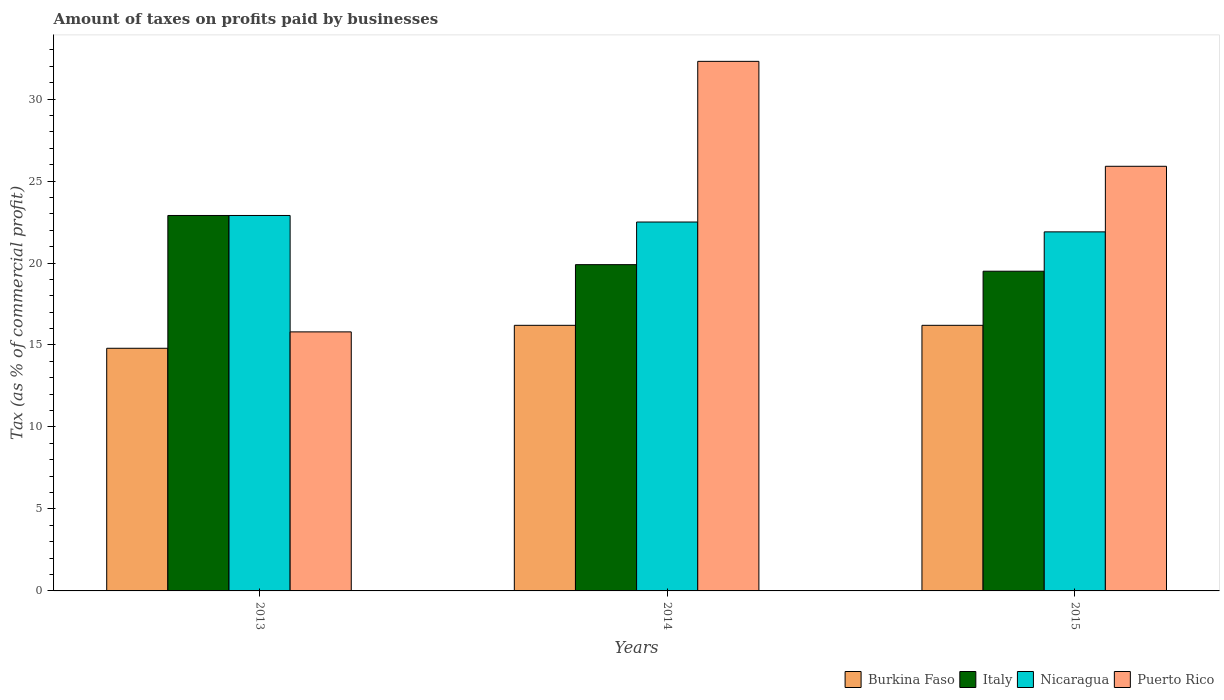How many groups of bars are there?
Offer a very short reply. 3. Are the number of bars per tick equal to the number of legend labels?
Provide a short and direct response. Yes. Are the number of bars on each tick of the X-axis equal?
Ensure brevity in your answer.  Yes. How many bars are there on the 1st tick from the right?
Provide a succinct answer. 4. What is the label of the 1st group of bars from the left?
Offer a very short reply. 2013. What is the percentage of taxes paid by businesses in Italy in 2015?
Your response must be concise. 19.5. Across all years, what is the maximum percentage of taxes paid by businesses in Italy?
Offer a very short reply. 22.9. In which year was the percentage of taxes paid by businesses in Italy maximum?
Provide a succinct answer. 2013. In which year was the percentage of taxes paid by businesses in Nicaragua minimum?
Your response must be concise. 2015. What is the difference between the percentage of taxes paid by businesses in Nicaragua in 2013 and that in 2014?
Ensure brevity in your answer.  0.4. What is the difference between the percentage of taxes paid by businesses in Nicaragua in 2015 and the percentage of taxes paid by businesses in Puerto Rico in 2013?
Provide a succinct answer. 6.1. What is the average percentage of taxes paid by businesses in Nicaragua per year?
Offer a very short reply. 22.43. In the year 2015, what is the difference between the percentage of taxes paid by businesses in Italy and percentage of taxes paid by businesses in Burkina Faso?
Your response must be concise. 3.3. What is the ratio of the percentage of taxes paid by businesses in Burkina Faso in 2013 to that in 2014?
Keep it short and to the point. 0.91. What is the difference between the highest and the second highest percentage of taxes paid by businesses in Puerto Rico?
Provide a succinct answer. 6.4. What is the difference between the highest and the lowest percentage of taxes paid by businesses in Italy?
Your response must be concise. 3.4. Is the sum of the percentage of taxes paid by businesses in Burkina Faso in 2013 and 2014 greater than the maximum percentage of taxes paid by businesses in Puerto Rico across all years?
Your answer should be very brief. No. What does the 4th bar from the left in 2014 represents?
Offer a very short reply. Puerto Rico. How many bars are there?
Offer a very short reply. 12. Are all the bars in the graph horizontal?
Give a very brief answer. No. How many years are there in the graph?
Keep it short and to the point. 3. Does the graph contain grids?
Your answer should be very brief. No. How are the legend labels stacked?
Your answer should be compact. Horizontal. What is the title of the graph?
Give a very brief answer. Amount of taxes on profits paid by businesses. What is the label or title of the Y-axis?
Ensure brevity in your answer.  Tax (as % of commercial profit). What is the Tax (as % of commercial profit) of Italy in 2013?
Your answer should be compact. 22.9. What is the Tax (as % of commercial profit) in Nicaragua in 2013?
Ensure brevity in your answer.  22.9. What is the Tax (as % of commercial profit) of Burkina Faso in 2014?
Your response must be concise. 16.2. What is the Tax (as % of commercial profit) in Italy in 2014?
Provide a short and direct response. 19.9. What is the Tax (as % of commercial profit) of Puerto Rico in 2014?
Provide a short and direct response. 32.3. What is the Tax (as % of commercial profit) in Nicaragua in 2015?
Offer a terse response. 21.9. What is the Tax (as % of commercial profit) of Puerto Rico in 2015?
Provide a short and direct response. 25.9. Across all years, what is the maximum Tax (as % of commercial profit) in Italy?
Make the answer very short. 22.9. Across all years, what is the maximum Tax (as % of commercial profit) of Nicaragua?
Provide a succinct answer. 22.9. Across all years, what is the maximum Tax (as % of commercial profit) in Puerto Rico?
Offer a very short reply. 32.3. Across all years, what is the minimum Tax (as % of commercial profit) of Burkina Faso?
Give a very brief answer. 14.8. Across all years, what is the minimum Tax (as % of commercial profit) of Italy?
Make the answer very short. 19.5. Across all years, what is the minimum Tax (as % of commercial profit) in Nicaragua?
Give a very brief answer. 21.9. Across all years, what is the minimum Tax (as % of commercial profit) in Puerto Rico?
Ensure brevity in your answer.  15.8. What is the total Tax (as % of commercial profit) in Burkina Faso in the graph?
Offer a very short reply. 47.2. What is the total Tax (as % of commercial profit) in Italy in the graph?
Ensure brevity in your answer.  62.3. What is the total Tax (as % of commercial profit) in Nicaragua in the graph?
Your response must be concise. 67.3. What is the difference between the Tax (as % of commercial profit) in Italy in 2013 and that in 2014?
Your answer should be very brief. 3. What is the difference between the Tax (as % of commercial profit) in Nicaragua in 2013 and that in 2014?
Provide a succinct answer. 0.4. What is the difference between the Tax (as % of commercial profit) in Puerto Rico in 2013 and that in 2014?
Your response must be concise. -16.5. What is the difference between the Tax (as % of commercial profit) in Burkina Faso in 2013 and that in 2015?
Offer a terse response. -1.4. What is the difference between the Tax (as % of commercial profit) of Italy in 2013 and that in 2015?
Provide a short and direct response. 3.4. What is the difference between the Tax (as % of commercial profit) of Nicaragua in 2014 and that in 2015?
Ensure brevity in your answer.  0.6. What is the difference between the Tax (as % of commercial profit) of Puerto Rico in 2014 and that in 2015?
Your answer should be very brief. 6.4. What is the difference between the Tax (as % of commercial profit) of Burkina Faso in 2013 and the Tax (as % of commercial profit) of Italy in 2014?
Keep it short and to the point. -5.1. What is the difference between the Tax (as % of commercial profit) in Burkina Faso in 2013 and the Tax (as % of commercial profit) in Puerto Rico in 2014?
Make the answer very short. -17.5. What is the difference between the Tax (as % of commercial profit) in Italy in 2013 and the Tax (as % of commercial profit) in Nicaragua in 2014?
Your answer should be very brief. 0.4. What is the difference between the Tax (as % of commercial profit) of Nicaragua in 2013 and the Tax (as % of commercial profit) of Puerto Rico in 2014?
Make the answer very short. -9.4. What is the difference between the Tax (as % of commercial profit) in Burkina Faso in 2013 and the Tax (as % of commercial profit) in Italy in 2015?
Your answer should be compact. -4.7. What is the difference between the Tax (as % of commercial profit) in Burkina Faso in 2013 and the Tax (as % of commercial profit) in Nicaragua in 2015?
Provide a succinct answer. -7.1. What is the difference between the Tax (as % of commercial profit) of Burkina Faso in 2013 and the Tax (as % of commercial profit) of Puerto Rico in 2015?
Your answer should be very brief. -11.1. What is the difference between the Tax (as % of commercial profit) of Italy in 2013 and the Tax (as % of commercial profit) of Puerto Rico in 2015?
Give a very brief answer. -3. What is the difference between the Tax (as % of commercial profit) of Nicaragua in 2013 and the Tax (as % of commercial profit) of Puerto Rico in 2015?
Offer a terse response. -3. What is the difference between the Tax (as % of commercial profit) in Burkina Faso in 2014 and the Tax (as % of commercial profit) in Puerto Rico in 2015?
Keep it short and to the point. -9.7. What is the difference between the Tax (as % of commercial profit) of Italy in 2014 and the Tax (as % of commercial profit) of Nicaragua in 2015?
Offer a very short reply. -2. What is the difference between the Tax (as % of commercial profit) of Nicaragua in 2014 and the Tax (as % of commercial profit) of Puerto Rico in 2015?
Give a very brief answer. -3.4. What is the average Tax (as % of commercial profit) in Burkina Faso per year?
Offer a very short reply. 15.73. What is the average Tax (as % of commercial profit) of Italy per year?
Ensure brevity in your answer.  20.77. What is the average Tax (as % of commercial profit) of Nicaragua per year?
Provide a short and direct response. 22.43. What is the average Tax (as % of commercial profit) in Puerto Rico per year?
Keep it short and to the point. 24.67. In the year 2013, what is the difference between the Tax (as % of commercial profit) in Burkina Faso and Tax (as % of commercial profit) in Italy?
Make the answer very short. -8.1. In the year 2013, what is the difference between the Tax (as % of commercial profit) of Italy and Tax (as % of commercial profit) of Puerto Rico?
Offer a terse response. 7.1. In the year 2014, what is the difference between the Tax (as % of commercial profit) of Burkina Faso and Tax (as % of commercial profit) of Italy?
Offer a terse response. -3.7. In the year 2014, what is the difference between the Tax (as % of commercial profit) of Burkina Faso and Tax (as % of commercial profit) of Puerto Rico?
Your response must be concise. -16.1. In the year 2014, what is the difference between the Tax (as % of commercial profit) of Italy and Tax (as % of commercial profit) of Puerto Rico?
Keep it short and to the point. -12.4. In the year 2014, what is the difference between the Tax (as % of commercial profit) of Nicaragua and Tax (as % of commercial profit) of Puerto Rico?
Provide a succinct answer. -9.8. In the year 2015, what is the difference between the Tax (as % of commercial profit) of Burkina Faso and Tax (as % of commercial profit) of Italy?
Your response must be concise. -3.3. In the year 2015, what is the difference between the Tax (as % of commercial profit) of Burkina Faso and Tax (as % of commercial profit) of Nicaragua?
Your answer should be compact. -5.7. In the year 2015, what is the difference between the Tax (as % of commercial profit) of Burkina Faso and Tax (as % of commercial profit) of Puerto Rico?
Keep it short and to the point. -9.7. In the year 2015, what is the difference between the Tax (as % of commercial profit) of Italy and Tax (as % of commercial profit) of Nicaragua?
Your answer should be compact. -2.4. What is the ratio of the Tax (as % of commercial profit) of Burkina Faso in 2013 to that in 2014?
Your answer should be compact. 0.91. What is the ratio of the Tax (as % of commercial profit) in Italy in 2013 to that in 2014?
Give a very brief answer. 1.15. What is the ratio of the Tax (as % of commercial profit) in Nicaragua in 2013 to that in 2014?
Make the answer very short. 1.02. What is the ratio of the Tax (as % of commercial profit) in Puerto Rico in 2013 to that in 2014?
Keep it short and to the point. 0.49. What is the ratio of the Tax (as % of commercial profit) of Burkina Faso in 2013 to that in 2015?
Ensure brevity in your answer.  0.91. What is the ratio of the Tax (as % of commercial profit) in Italy in 2013 to that in 2015?
Give a very brief answer. 1.17. What is the ratio of the Tax (as % of commercial profit) of Nicaragua in 2013 to that in 2015?
Offer a very short reply. 1.05. What is the ratio of the Tax (as % of commercial profit) of Puerto Rico in 2013 to that in 2015?
Give a very brief answer. 0.61. What is the ratio of the Tax (as % of commercial profit) in Burkina Faso in 2014 to that in 2015?
Give a very brief answer. 1. What is the ratio of the Tax (as % of commercial profit) in Italy in 2014 to that in 2015?
Keep it short and to the point. 1.02. What is the ratio of the Tax (as % of commercial profit) in Nicaragua in 2014 to that in 2015?
Keep it short and to the point. 1.03. What is the ratio of the Tax (as % of commercial profit) in Puerto Rico in 2014 to that in 2015?
Ensure brevity in your answer.  1.25. What is the difference between the highest and the second highest Tax (as % of commercial profit) of Italy?
Keep it short and to the point. 3. What is the difference between the highest and the lowest Tax (as % of commercial profit) of Burkina Faso?
Ensure brevity in your answer.  1.4. What is the difference between the highest and the lowest Tax (as % of commercial profit) of Italy?
Make the answer very short. 3.4. What is the difference between the highest and the lowest Tax (as % of commercial profit) in Nicaragua?
Provide a short and direct response. 1. 